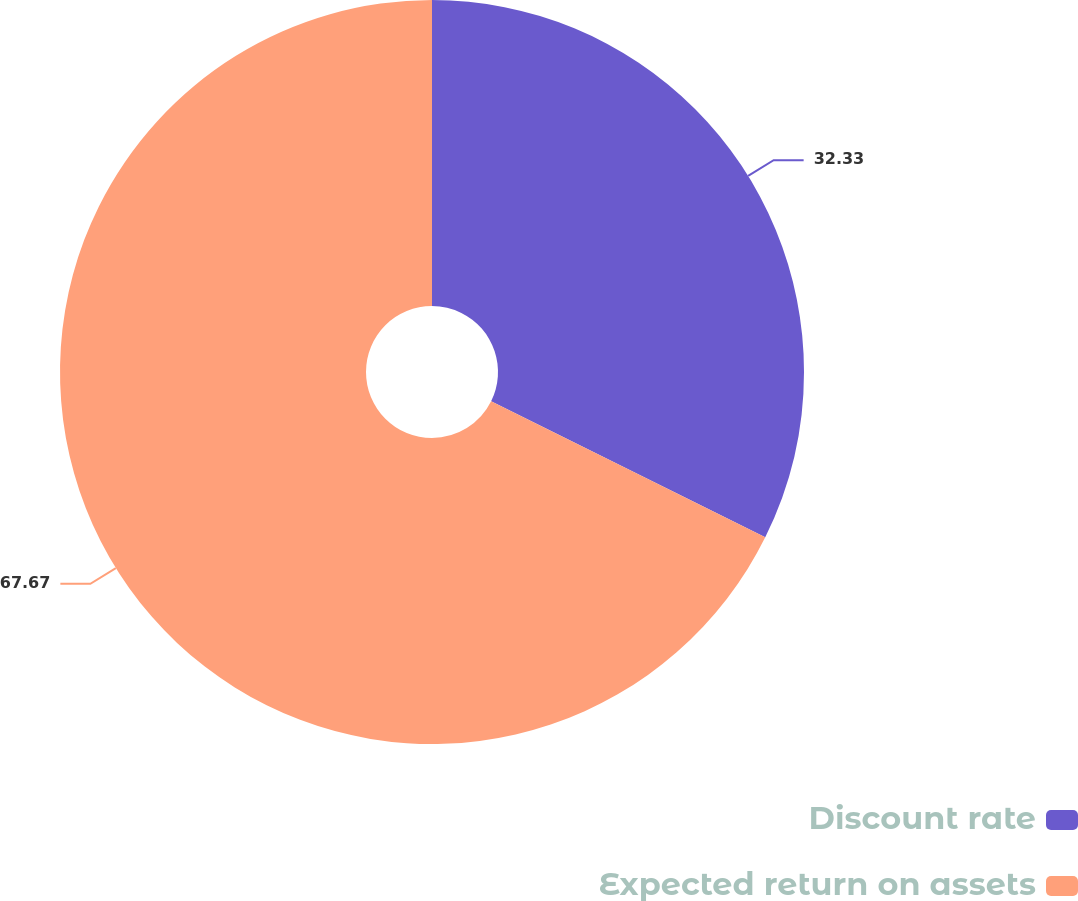Convert chart. <chart><loc_0><loc_0><loc_500><loc_500><pie_chart><fcel>Discount rate<fcel>Expected return on assets<nl><fcel>32.33%<fcel>67.67%<nl></chart> 